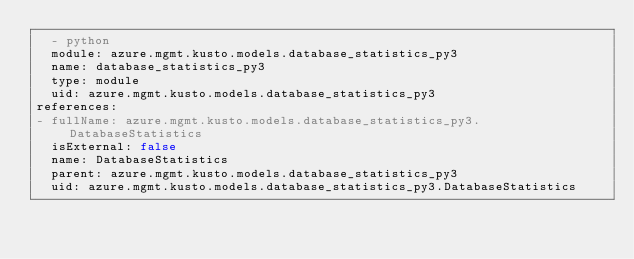Convert code to text. <code><loc_0><loc_0><loc_500><loc_500><_YAML_>  - python
  module: azure.mgmt.kusto.models.database_statistics_py3
  name: database_statistics_py3
  type: module
  uid: azure.mgmt.kusto.models.database_statistics_py3
references:
- fullName: azure.mgmt.kusto.models.database_statistics_py3.DatabaseStatistics
  isExternal: false
  name: DatabaseStatistics
  parent: azure.mgmt.kusto.models.database_statistics_py3
  uid: azure.mgmt.kusto.models.database_statistics_py3.DatabaseStatistics
</code> 